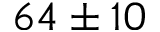Convert formula to latex. <formula><loc_0><loc_0><loc_500><loc_500>6 4 \pm 1 0</formula> 